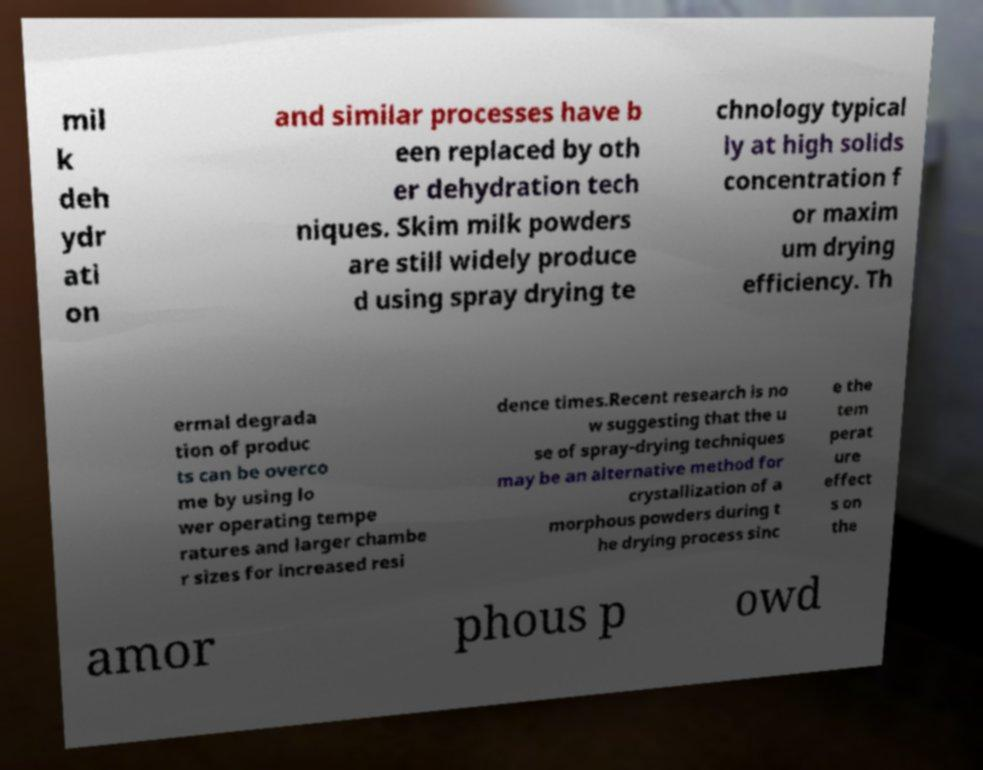Could you extract and type out the text from this image? mil k deh ydr ati on and similar processes have b een replaced by oth er dehydration tech niques. Skim milk powders are still widely produce d using spray drying te chnology typical ly at high solids concentration f or maxim um drying efficiency. Th ermal degrada tion of produc ts can be overco me by using lo wer operating tempe ratures and larger chambe r sizes for increased resi dence times.Recent research is no w suggesting that the u se of spray-drying techniques may be an alternative method for crystallization of a morphous powders during t he drying process sinc e the tem perat ure effect s on the amor phous p owd 